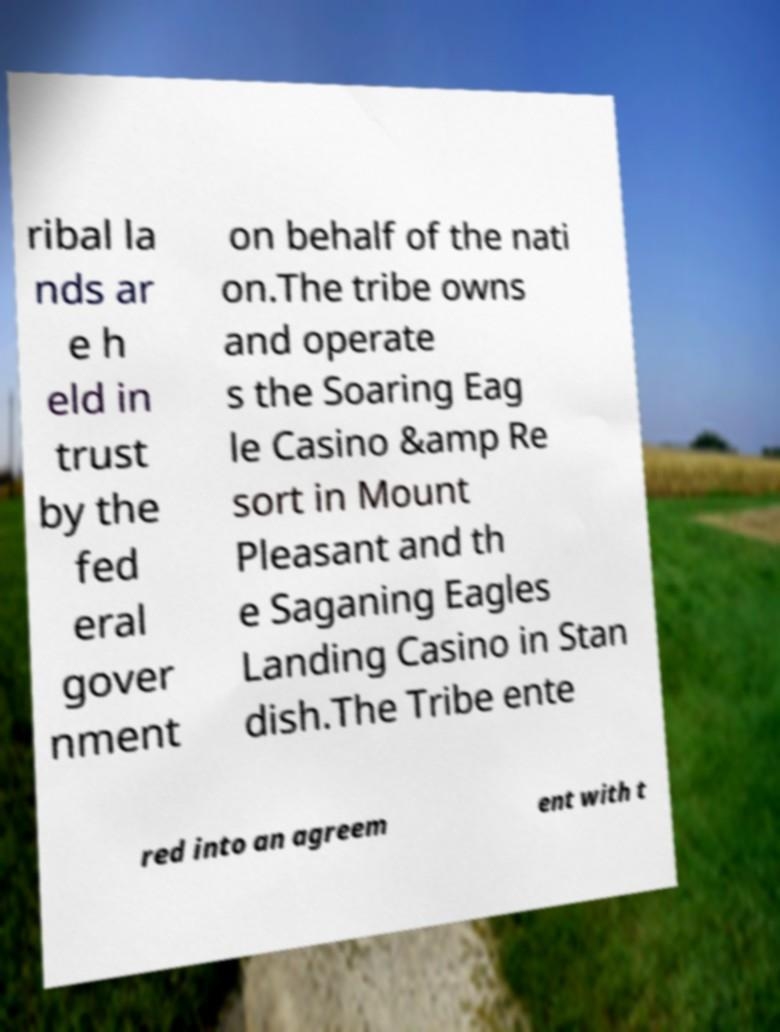Could you assist in decoding the text presented in this image and type it out clearly? ribal la nds ar e h eld in trust by the fed eral gover nment on behalf of the nati on.The tribe owns and operate s the Soaring Eag le Casino &amp Re sort in Mount Pleasant and th e Saganing Eagles Landing Casino in Stan dish.The Tribe ente red into an agreem ent with t 